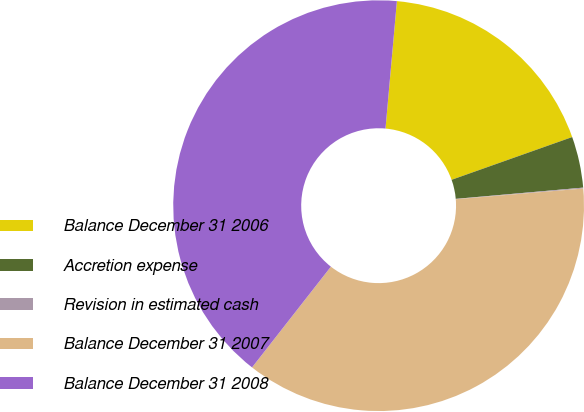Convert chart to OTSL. <chart><loc_0><loc_0><loc_500><loc_500><pie_chart><fcel>Balance December 31 2006<fcel>Accretion expense<fcel>Revision in estimated cash<fcel>Balance December 31 2007<fcel>Balance December 31 2008<nl><fcel>18.16%<fcel>4.02%<fcel>0.07%<fcel>36.9%<fcel>40.85%<nl></chart> 